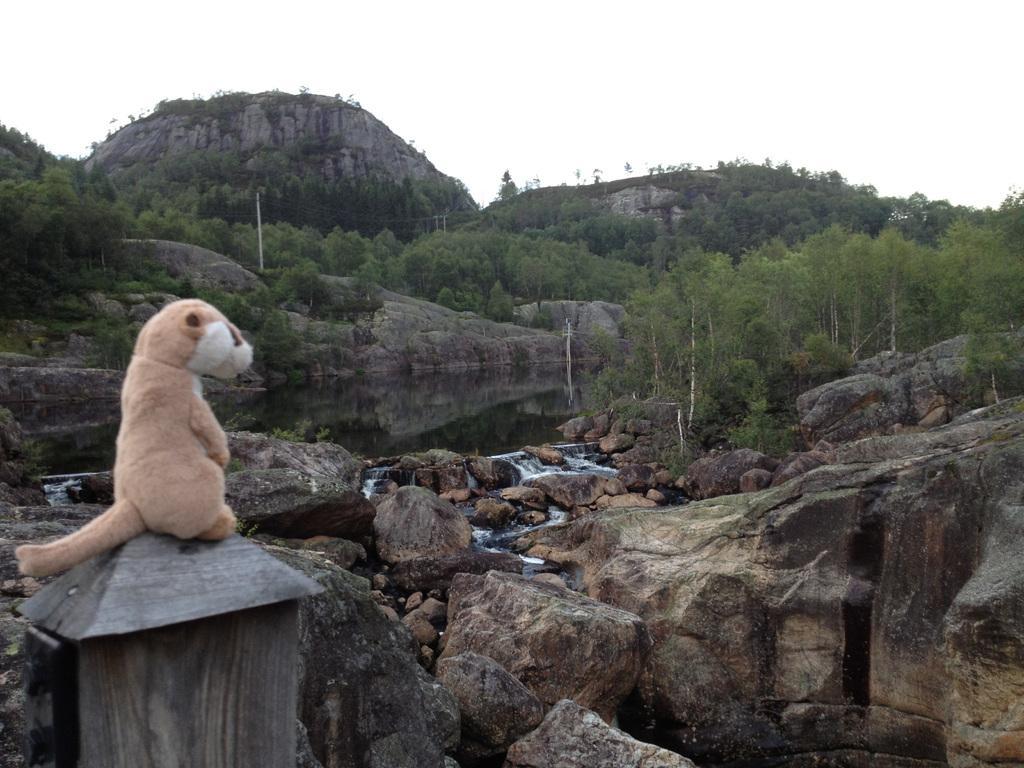Please provide a concise description of this image. In the bottom left corner of the image we can see a wooden object, on the wooden object we can see a doll. In the middle of the image we can see some stones, water, trees, hills and poles. At the top of the image we can see the sky. 